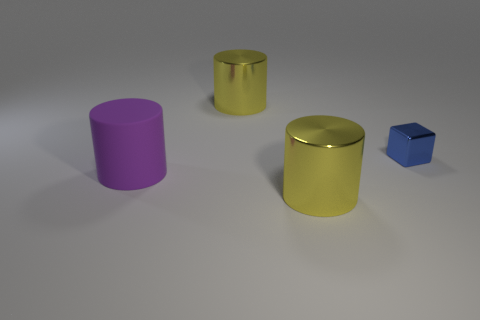Is there any other thing that has the same shape as the blue object?
Give a very brief answer. No. What number of shiny objects are behind the rubber thing and to the left of the small metallic thing?
Your response must be concise. 1. Is the size of the purple matte object the same as the blue shiny block?
Provide a short and direct response. No. Is the size of the yellow metallic cylinder in front of the metallic block the same as the cube?
Provide a short and direct response. No. There is a shiny thing that is behind the tiny shiny object; what is its color?
Your answer should be very brief. Yellow. How many big things are there?
Your answer should be very brief. 3. Does the big thing that is behind the small block have the same color as the metallic object that is in front of the blue metallic object?
Provide a succinct answer. Yes. Is the number of purple rubber cylinders that are left of the large purple rubber object the same as the number of large rubber cylinders?
Give a very brief answer. No. How many cylinders are in front of the small blue metal object?
Your answer should be compact. 2. What size is the metal block?
Make the answer very short. Small. 